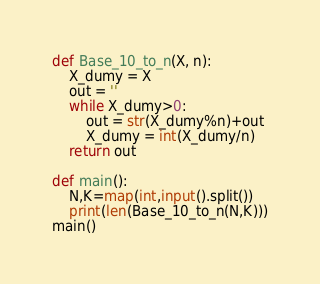Convert code to text. <code><loc_0><loc_0><loc_500><loc_500><_Python_>def Base_10_to_n(X, n):
    X_dumy = X
    out = ''
    while X_dumy>0:
        out = str(X_dumy%n)+out
        X_dumy = int(X_dumy/n)
    return out
    
def main():
    N,K=map(int,input().split())
    print(len(Base_10_to_n(N,K)))
main()</code> 